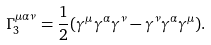Convert formula to latex. <formula><loc_0><loc_0><loc_500><loc_500>\Gamma _ { 3 } ^ { \mu \alpha \nu } = \frac { 1 } { 2 } ( \gamma ^ { \mu } \gamma ^ { \alpha } \gamma ^ { \nu } - \gamma ^ { \nu } \gamma ^ { \alpha } \gamma ^ { \mu } ) .</formula> 